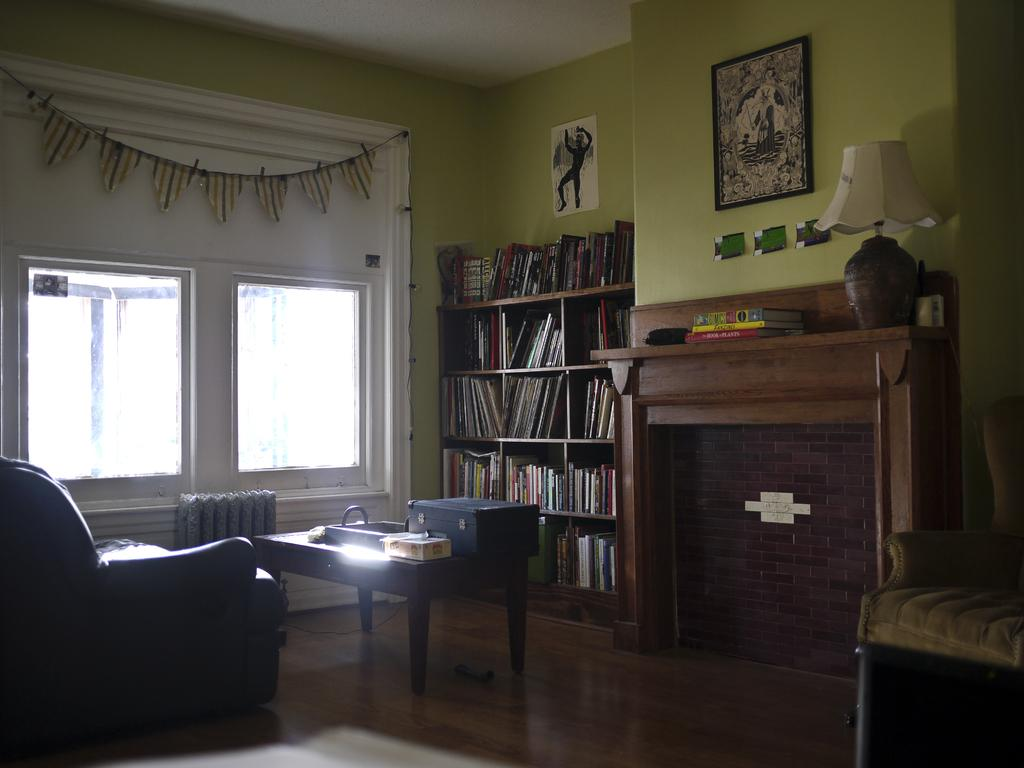What type of furniture is located in the left corner of the image? There is a black sofa in the left corner of the image. What can be found in the right corner of the image? There is a bookshelf in the right corner of the image. What is situated between the sofa and the bookshelf? There is a table between the sofa and the bookshelf. What is visible in the background of the image? There is a window in the background of the image. What color is the wall in the image? The wall is green in color. What type of ice is being used to keep the bookshelf cool in the image? There is no ice present in the image, and the bookshelf is not being cooled by ice. 